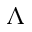Convert formula to latex. <formula><loc_0><loc_0><loc_500><loc_500>\Lambda</formula> 